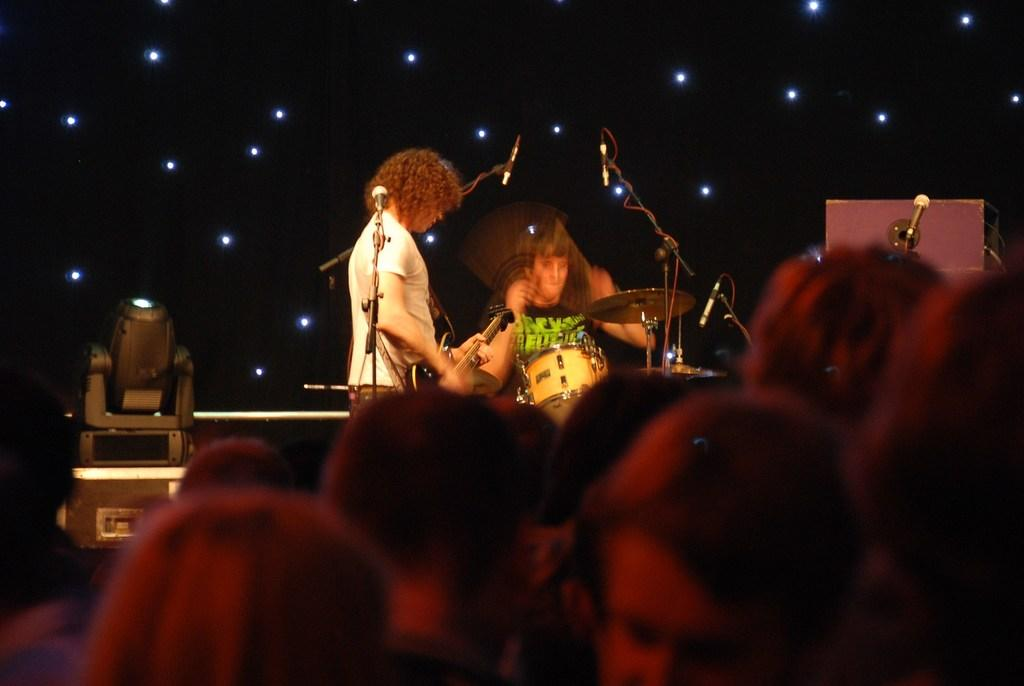How many persons are playing musical instruments in the image? There are two persons playing musical instruments in the image. What equipment is present for amplifying sound? There are mikes in the image. What can be seen in the image that provides illumination? There are lights in the image. Where are the people located in the image? There are people at the bottom of the image. What type of plot is being discussed by the frogs in the image? There are no frogs present in the image, so there is no discussion or plot to be analyzed. 